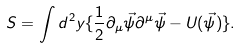Convert formula to latex. <formula><loc_0><loc_0><loc_500><loc_500>S = \int d ^ { 2 } y \{ \frac { 1 } { 2 } \partial _ { \mu } \vec { \psi } \partial ^ { \mu } \vec { \psi } - U ( \vec { \psi } ) \} .</formula> 